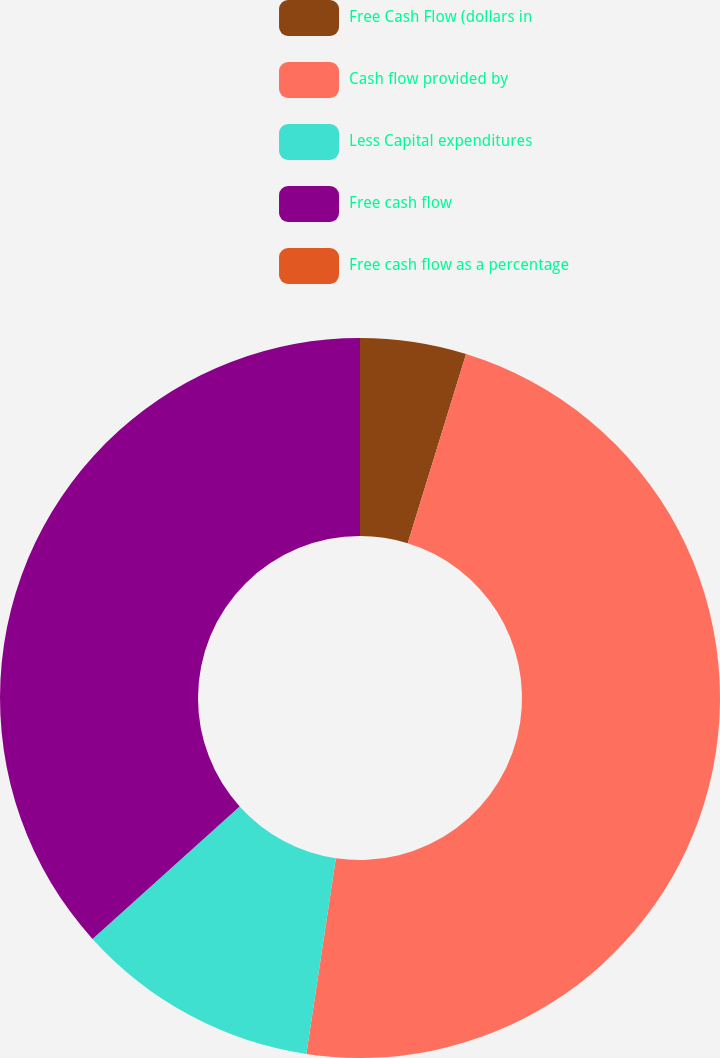<chart> <loc_0><loc_0><loc_500><loc_500><pie_chart><fcel>Free Cash Flow (dollars in<fcel>Cash flow provided by<fcel>Less Capital expenditures<fcel>Free cash flow<fcel>Free cash flow as a percentage<nl><fcel>4.76%<fcel>47.62%<fcel>10.95%<fcel>36.67%<fcel>0.0%<nl></chart> 